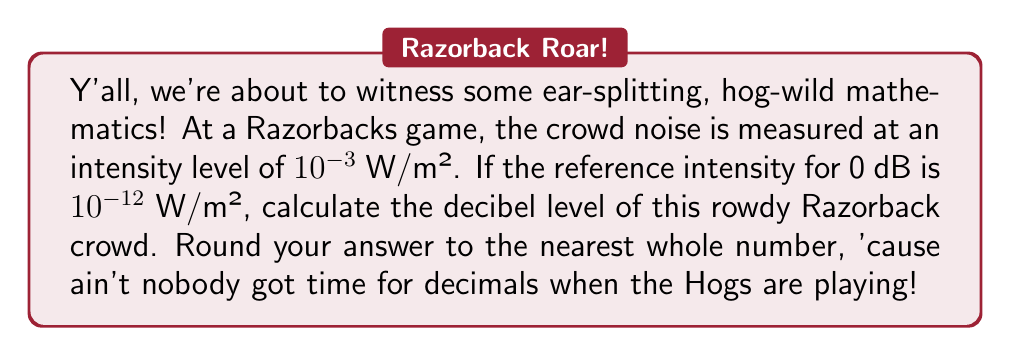Teach me how to tackle this problem. Alright, pigskin mathematicians, let's break this down faster than a Razorback defensive line!

1) The formula for decibel level is:
   $$ dB = 10 \log_{10}\left(\frac{I}{I_0}\right) $$
   where $I$ is the intensity of the sound and $I_0$ is the reference intensity.

2) We're given:
   $I = 10^{-3}$ W/m² (our hog-wild crowd)
   $I_0 = 10^{-12}$ W/m² (reference intensity)

3) Let's plug these numbers into our formula:
   $$ dB = 10 \log_{10}\left(\frac{10^{-3}}{10^{-12}}\right) $$

4) Now, let's simplify what's inside the parentheses:
   $$ dB = 10 \log_{10}(10^{9}) $$

5) Remember, folks, $\log_{10}(10^x) = x$. It's as simple as a touchdown!
   $$ dB = 10 \cdot 9 = 90 $$

6) We're asked to round to the nearest whole number, but we're already there!

So, there you have it, Razorback fans! The decibel level is a whopping 90 dB!
Answer: 90 dB 